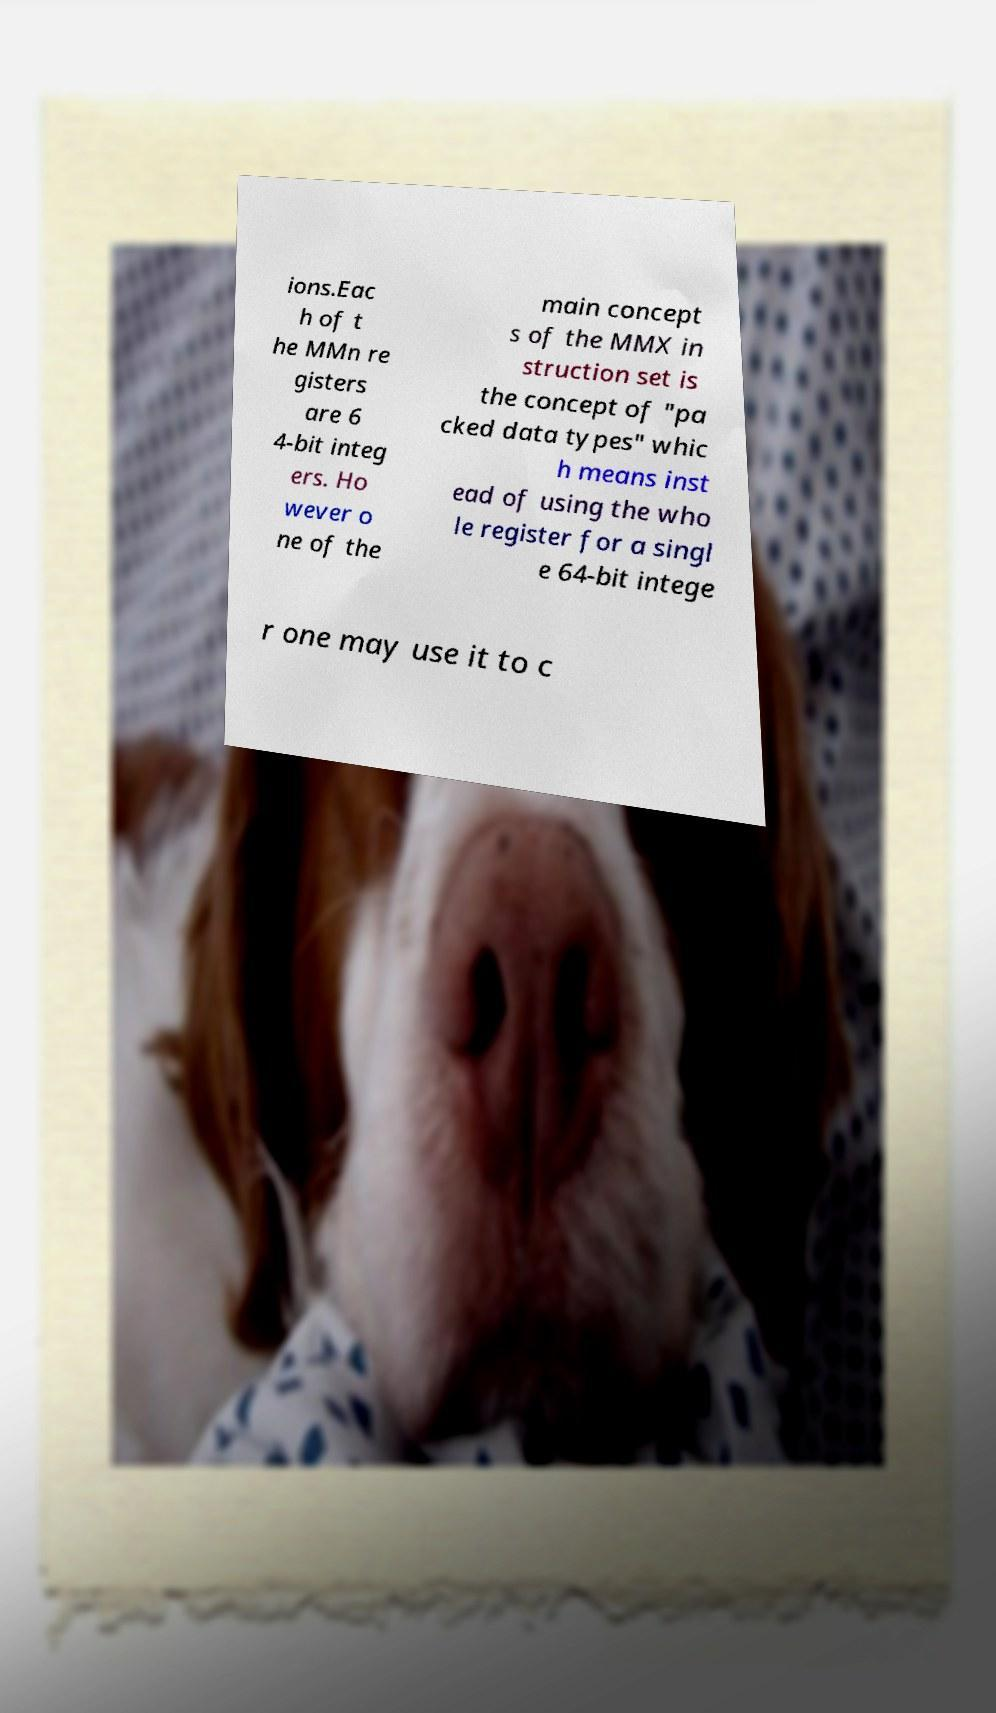I need the written content from this picture converted into text. Can you do that? ions.Eac h of t he MMn re gisters are 6 4-bit integ ers. Ho wever o ne of the main concept s of the MMX in struction set is the concept of "pa cked data types" whic h means inst ead of using the who le register for a singl e 64-bit intege r one may use it to c 